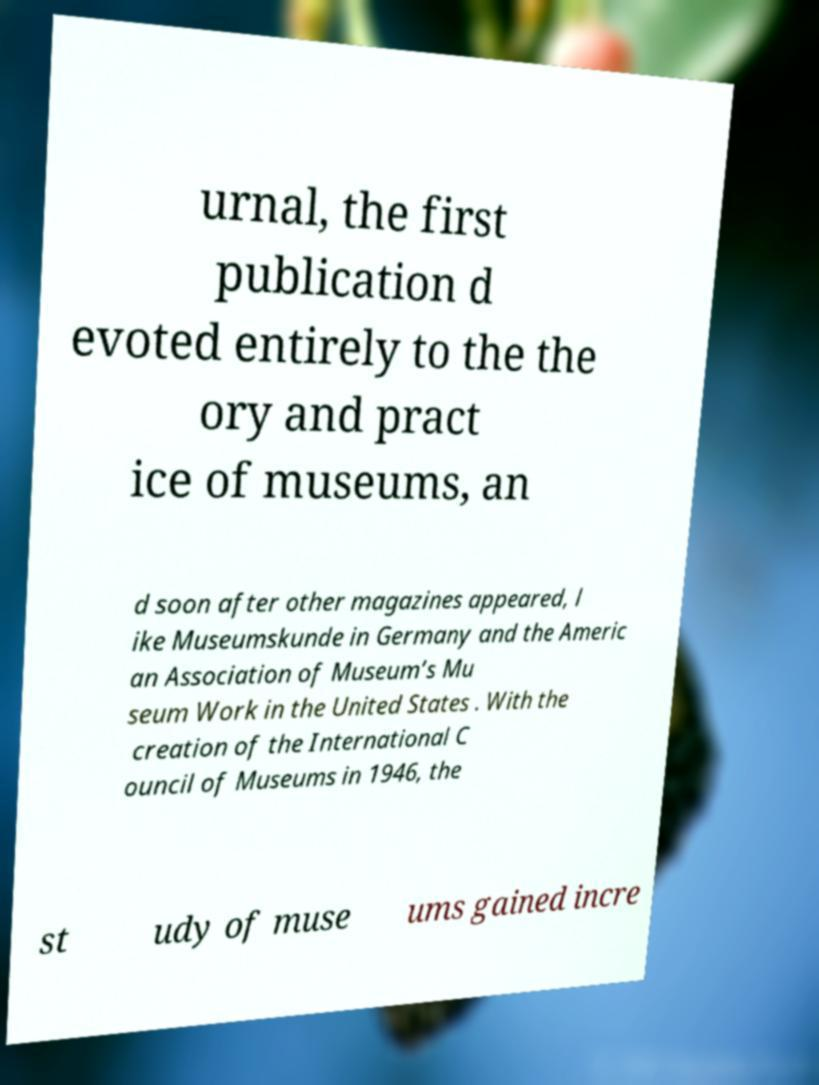Can you read and provide the text displayed in the image?This photo seems to have some interesting text. Can you extract and type it out for me? urnal, the first publication d evoted entirely to the the ory and pract ice of museums, an d soon after other magazines appeared, l ike Museumskunde in Germany and the Americ an Association of Museum’s Mu seum Work in the United States . With the creation of the International C ouncil of Museums in 1946, the st udy of muse ums gained incre 